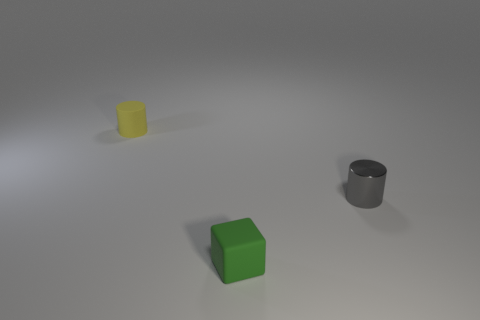Add 3 small metal cylinders. How many objects exist? 6 Subtract all cylinders. How many objects are left? 1 Add 2 small objects. How many small objects are left? 5 Add 2 red rubber spheres. How many red rubber spheres exist? 2 Subtract 0 red cubes. How many objects are left? 3 Subtract all tiny matte cylinders. Subtract all small yellow cylinders. How many objects are left? 1 